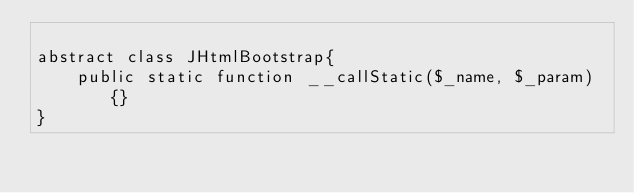<code> <loc_0><loc_0><loc_500><loc_500><_PHP_>
abstract class JHtmlBootstrap{
    public static function __callStatic($_name, $_param){}
}
</code> 